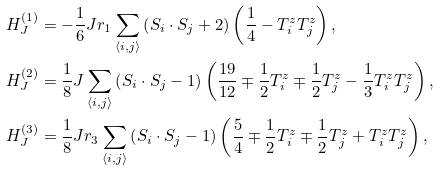Convert formula to latex. <formula><loc_0><loc_0><loc_500><loc_500>H ^ { ( 1 ) } _ { J } & = - \frac { 1 } { 6 } J r _ { 1 } \sum _ { \langle i , j \rangle } \left ( { S } _ { i } \cdot { S } _ { j } + 2 \right ) \left ( \frac { 1 } { 4 } - T ^ { z } _ { i } T ^ { z } _ { j } \right ) , \\ H ^ { ( 2 ) } _ { J } & = \frac { 1 } { 8 } J \sum _ { \langle i , j \rangle } \left ( { S } _ { i } \cdot { S } _ { j } - 1 \right ) \left ( \frac { 1 9 } { 1 2 } \mp \frac { 1 } { 2 } T ^ { z } _ { i } \mp \frac { 1 } { 2 } T ^ { z } _ { j } - \frac { 1 } { 3 } T ^ { z } _ { i } T ^ { z } _ { j } \right ) , \\ H ^ { ( 3 ) } _ { J } & = \frac { 1 } { 8 } J r _ { 3 } \sum _ { \langle i , j \rangle } \left ( { S } _ { i } \cdot { S } _ { j } - 1 \right ) \left ( \frac { 5 } { 4 } \mp \frac { 1 } { 2 } T ^ { z } _ { i } \mp \frac { 1 } { 2 } T ^ { z } _ { j } + T ^ { z } _ { i } T ^ { z } _ { j } \right ) ,</formula> 